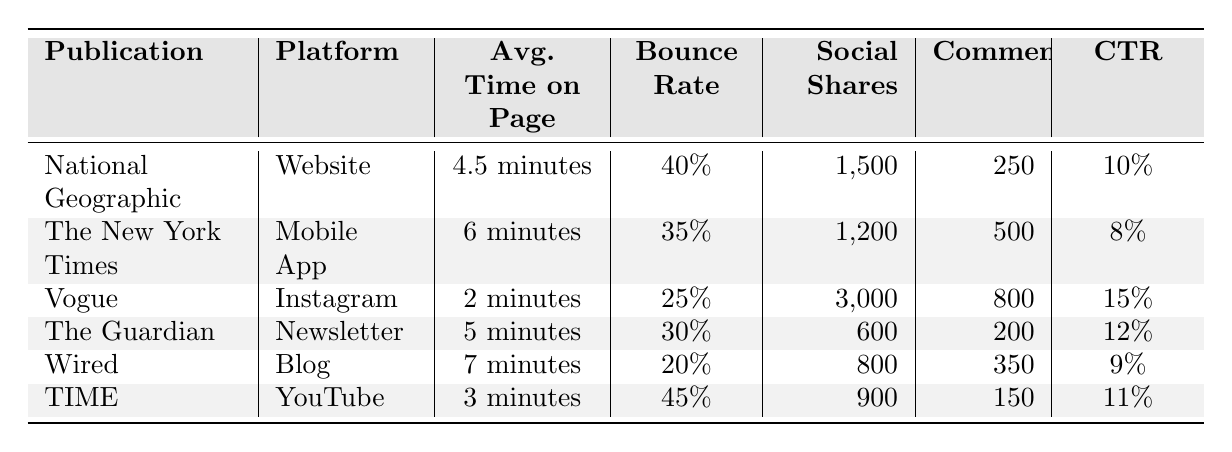What is the average time on the page for Vogue? The table shows that the average time on the page for Vogue is 2 minutes.
Answer: 2 minutes Which publication had the highest number of social shares? Looking at the Social Shares column, Vogue has the highest number with 3,000 shares.
Answer: Vogue What is the bounce rate for The Guardian? The bounce rate for The Guardian, as indicated in the table, is 30%.
Answer: 30% Calculate the average click-through rate (CTR) for all publications. First, we add the CTR values: (10% + 8% + 15% + 12% + 9% + 11%) = 65%. There are 6 publications, so we divide the total (65% / 6) = approximately 10.83%.
Answer: 10.83% Is the average time on page for the Mobile App of The New York Times greater than that for TIME’s YouTube platform? The average time on page for The New York Times is 6 minutes, while TIME’s average is 3 minutes. Since 6 minutes is greater than 3 minutes, the statement is true.
Answer: Yes Which publication has the lowest bounce rate? By examining the Bounce Rate column, we see that Wired has the lowest bounce rate at 20%.
Answer: Wired What is the difference in social shares between Vogue and National Geographic? Vogue has 3,000 social shares and National Geographic has 1,500 social shares. The difference is calculated as 3,000 - 1,500 = 1,500 shares.
Answer: 1,500 shares Are there more comments on The New York Times than on National Geographic? The New York Times has 500 comments and National Geographic has 250 comments. Since 500 is greater than 250, the answer is yes.
Answer: Yes What is the total number of comments across all publications? To find the total number of comments, we add: 250 + 500 + 800 + 200 + 350 + 150 = 2,300 comments.
Answer: 2,300 comments If we rank the publications by average time on page, which publication comes in 2nd place? Ranking by average time: 1st - Wired (7 minutes), 2nd - The New York Times (6 minutes), 3rd - The Guardian (5 minutes). The New York Times is in 2nd place.
Answer: The New York Times 